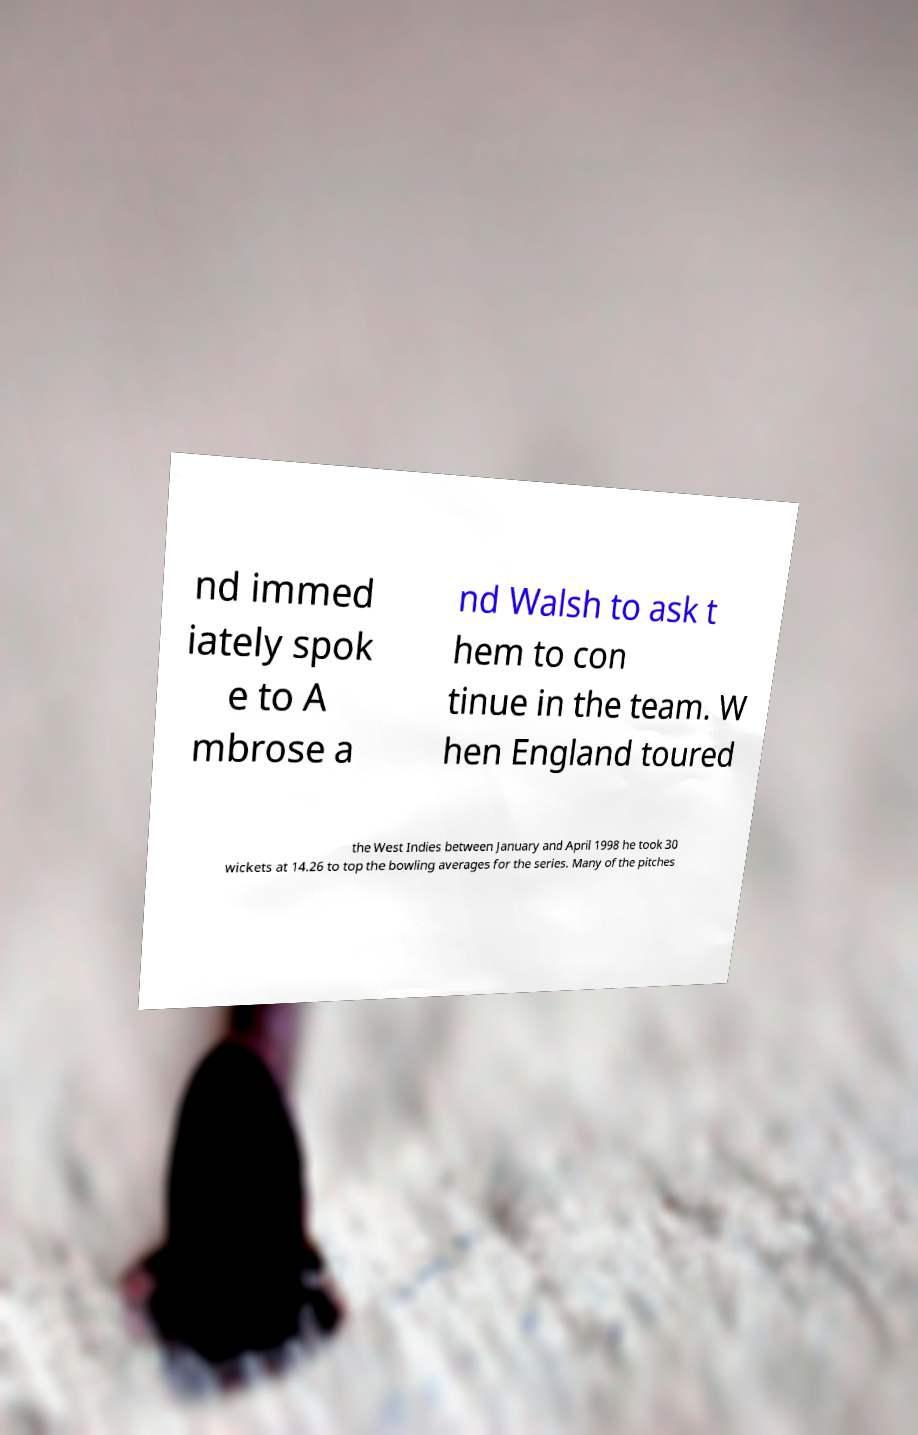Can you read and provide the text displayed in the image?This photo seems to have some interesting text. Can you extract and type it out for me? nd immed iately spok e to A mbrose a nd Walsh to ask t hem to con tinue in the team. W hen England toured the West Indies between January and April 1998 he took 30 wickets at 14.26 to top the bowling averages for the series. Many of the pitches 